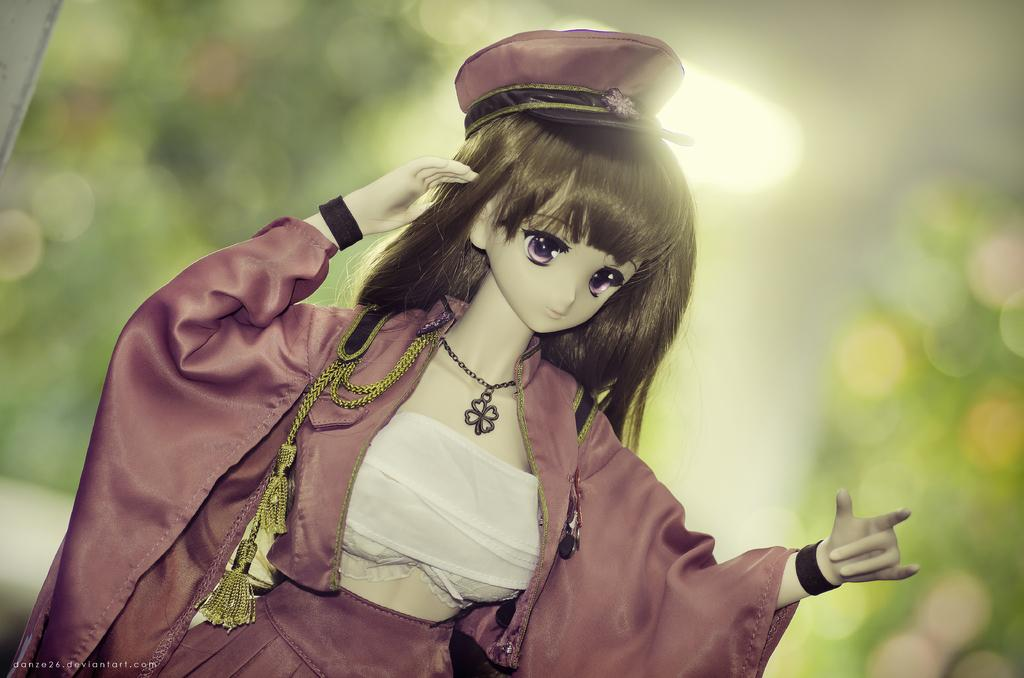What type of object is in the image? There is a toy of a woman in the image. What accessory does the toy have? The toy has a cap. What else is the toy wearing? The toy has clothes. How would you describe the background of the image? The background of the image is blurred. What color is the grape hanging from the curtain in the image? There is no grape or curtain present in the image; it features a toy of a woman with a cap and clothes. 